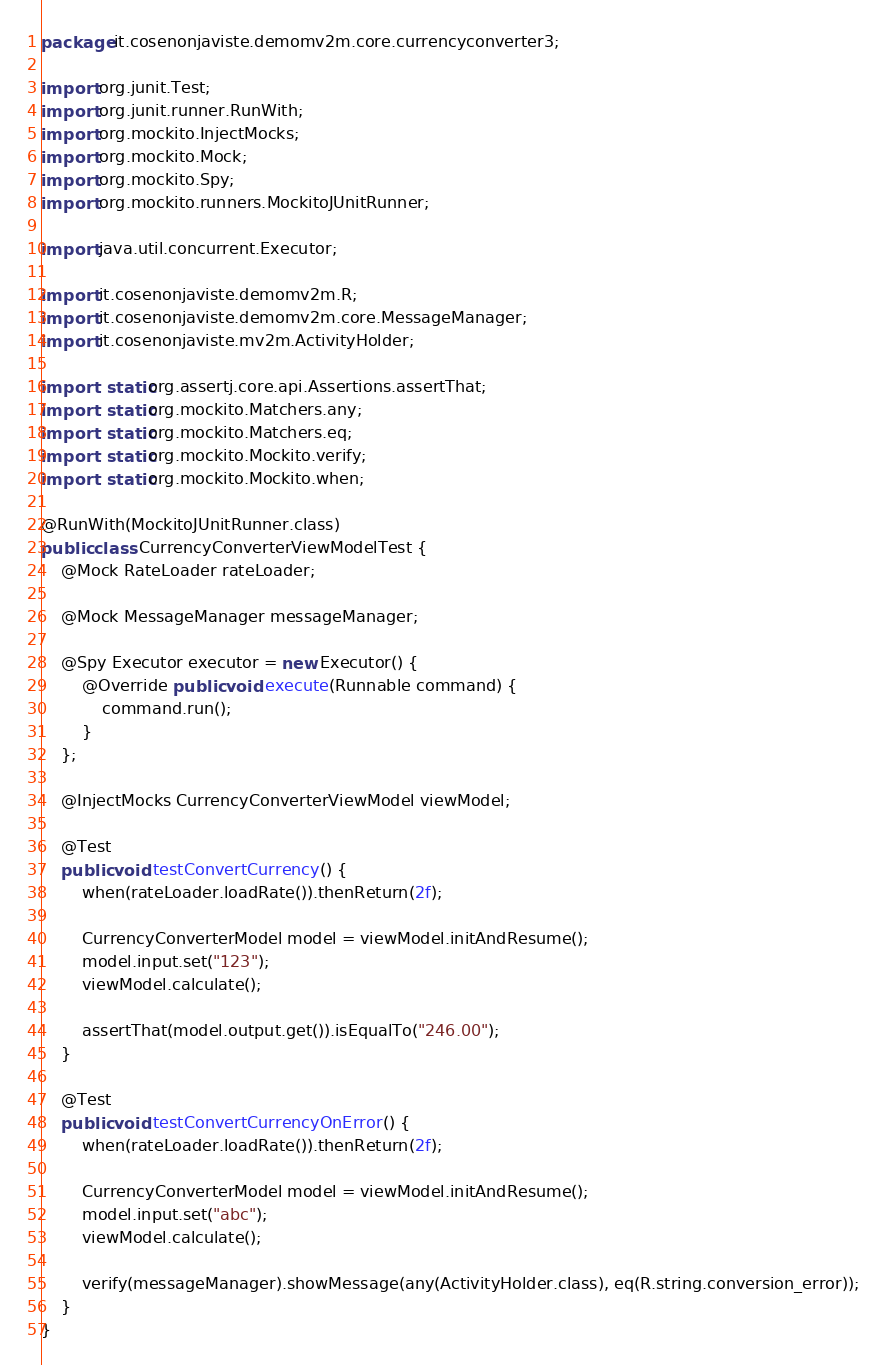<code> <loc_0><loc_0><loc_500><loc_500><_Java_>package it.cosenonjaviste.demomv2m.core.currencyconverter3;

import org.junit.Test;
import org.junit.runner.RunWith;
import org.mockito.InjectMocks;
import org.mockito.Mock;
import org.mockito.Spy;
import org.mockito.runners.MockitoJUnitRunner;

import java.util.concurrent.Executor;

import it.cosenonjaviste.demomv2m.R;
import it.cosenonjaviste.demomv2m.core.MessageManager;
import it.cosenonjaviste.mv2m.ActivityHolder;

import static org.assertj.core.api.Assertions.assertThat;
import static org.mockito.Matchers.any;
import static org.mockito.Matchers.eq;
import static org.mockito.Mockito.verify;
import static org.mockito.Mockito.when;

@RunWith(MockitoJUnitRunner.class)
public class CurrencyConverterViewModelTest {
    @Mock RateLoader rateLoader;

    @Mock MessageManager messageManager;

    @Spy Executor executor = new Executor() {
        @Override public void execute(Runnable command) {
            command.run();
        }
    };

    @InjectMocks CurrencyConverterViewModel viewModel;

    @Test
    public void testConvertCurrency() {
        when(rateLoader.loadRate()).thenReturn(2f);

        CurrencyConverterModel model = viewModel.initAndResume();
        model.input.set("123");
        viewModel.calculate();

        assertThat(model.output.get()).isEqualTo("246.00");
    }

    @Test
    public void testConvertCurrencyOnError() {
        when(rateLoader.loadRate()).thenReturn(2f);

        CurrencyConverterModel model = viewModel.initAndResume();
        model.input.set("abc");
        viewModel.calculate();

        verify(messageManager).showMessage(any(ActivityHolder.class), eq(R.string.conversion_error));
    }
}</code> 